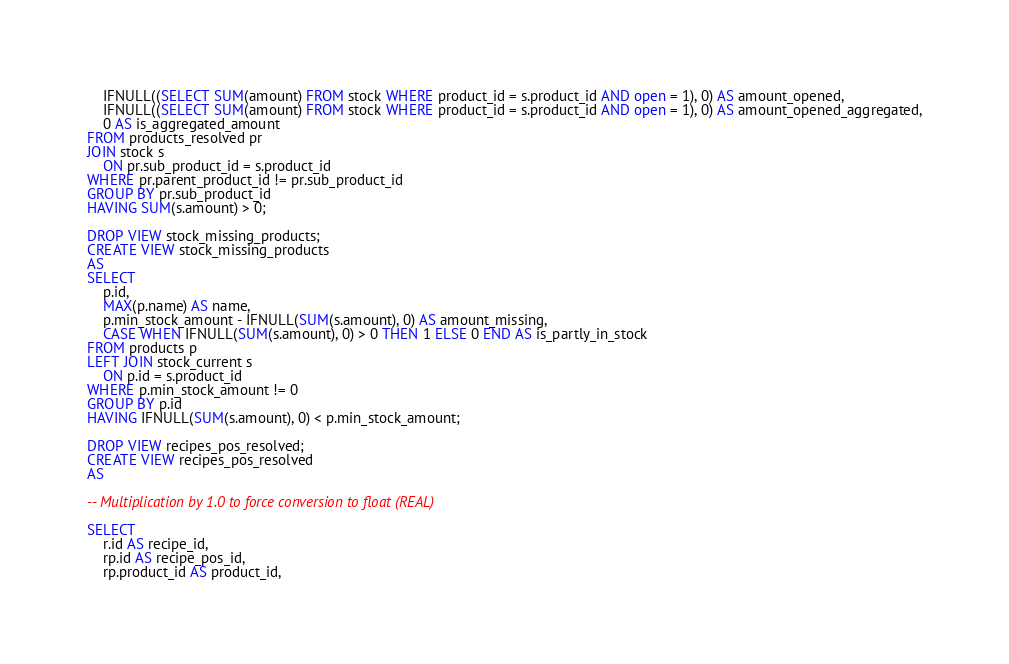<code> <loc_0><loc_0><loc_500><loc_500><_SQL_>	IFNULL((SELECT SUM(amount) FROM stock WHERE product_id = s.product_id AND open = 1), 0) AS amount_opened,
	IFNULL((SELECT SUM(amount) FROM stock WHERE product_id = s.product_id AND open = 1), 0) AS amount_opened_aggregated,
	0 AS is_aggregated_amount
FROM products_resolved pr
JOIN stock s
	ON pr.sub_product_id = s.product_id
WHERE pr.parent_product_id != pr.sub_product_id
GROUP BY pr.sub_product_id
HAVING SUM(s.amount) > 0;

DROP VIEW stock_missing_products;
CREATE VIEW stock_missing_products
AS
SELECT
	p.id,
	MAX(p.name) AS name,
	p.min_stock_amount - IFNULL(SUM(s.amount), 0) AS amount_missing,
	CASE WHEN IFNULL(SUM(s.amount), 0) > 0 THEN 1 ELSE 0 END AS is_partly_in_stock
FROM products p
LEFT JOIN stock_current s
	ON p.id = s.product_id
WHERE p.min_stock_amount != 0
GROUP BY p.id
HAVING IFNULL(SUM(s.amount), 0) < p.min_stock_amount;

DROP VIEW recipes_pos_resolved;
CREATE VIEW recipes_pos_resolved
AS

-- Multiplication by 1.0 to force conversion to float (REAL)

SELECT
	r.id AS recipe_id,
	rp.id AS recipe_pos_id,
	rp.product_id AS product_id,</code> 